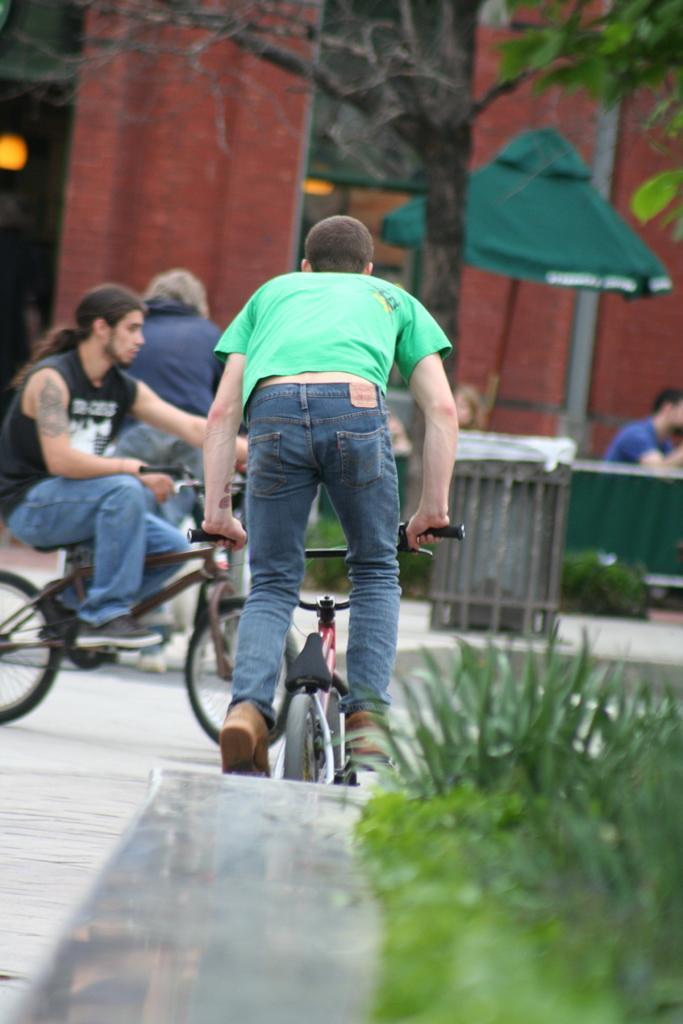Can you describe this image briefly? The image is outside of the city. In the image there are group of people two people are riding a bicycle. On right side there is man who is sitting in background we can also see trees,building,umbrella and there are some grass. 